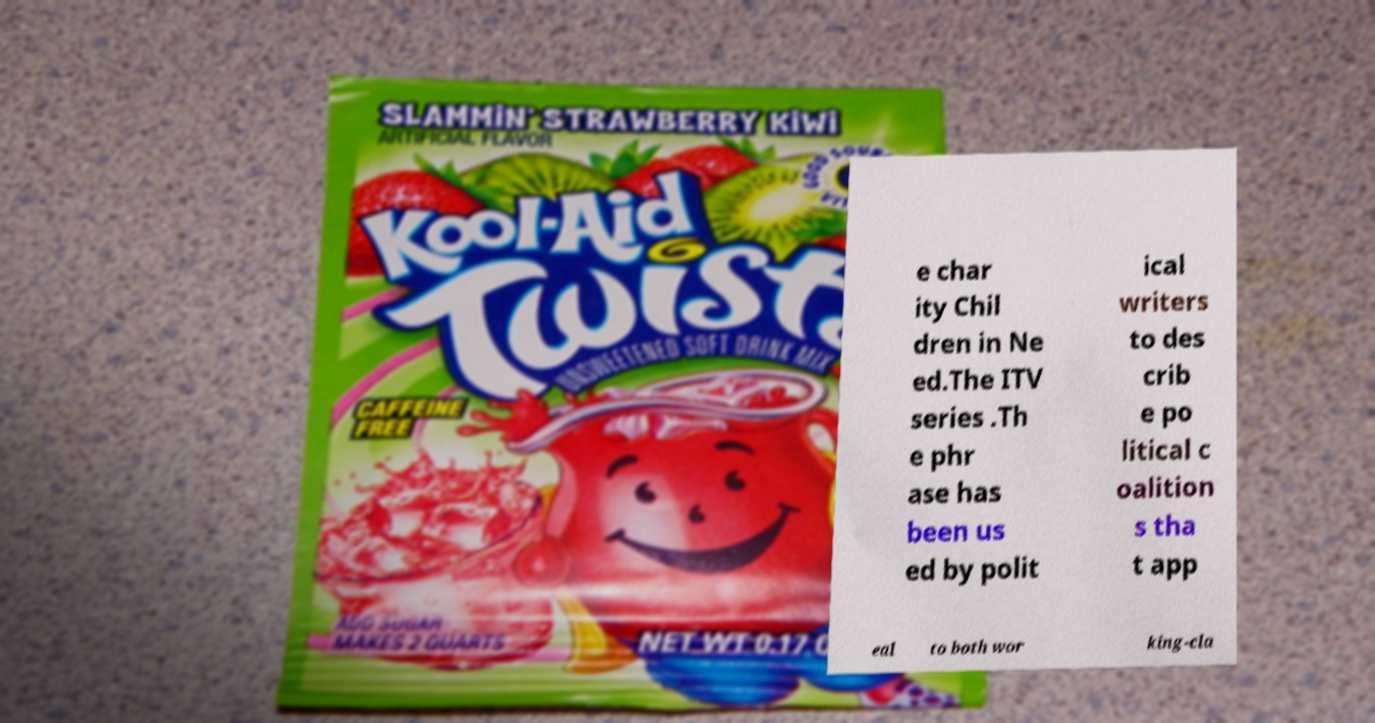Could you extract and type out the text from this image? e char ity Chil dren in Ne ed.The ITV series .Th e phr ase has been us ed by polit ical writers to des crib e po litical c oalition s tha t app eal to both wor king-cla 